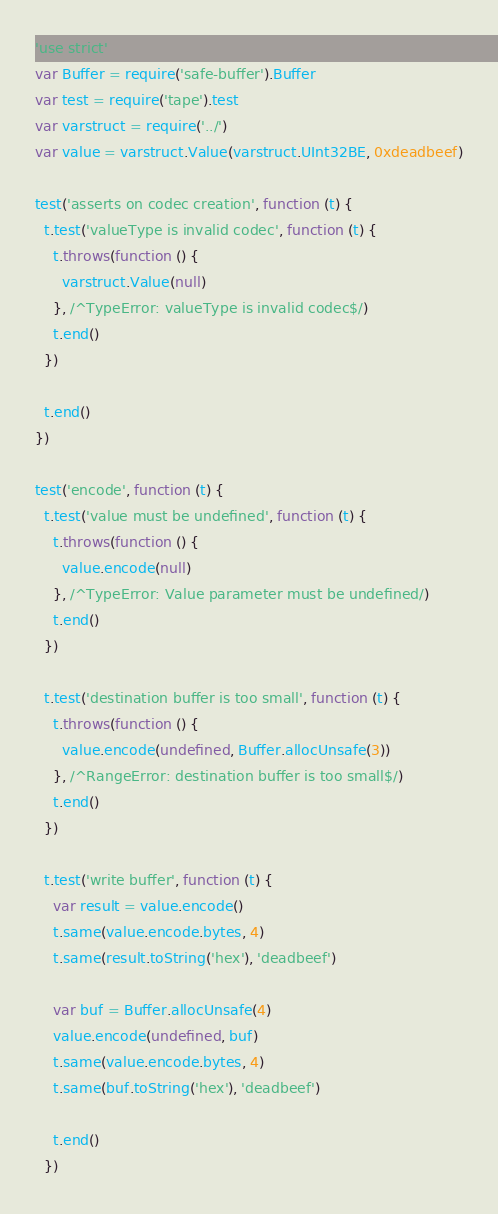<code> <loc_0><loc_0><loc_500><loc_500><_JavaScript_>'use strict'
var Buffer = require('safe-buffer').Buffer
var test = require('tape').test
var varstruct = require('../')
var value = varstruct.Value(varstruct.UInt32BE, 0xdeadbeef)

test('asserts on codec creation', function (t) {
  t.test('valueType is invalid codec', function (t) {
    t.throws(function () {
      varstruct.Value(null)
    }, /^TypeError: valueType is invalid codec$/)
    t.end()
  })

  t.end()
})

test('encode', function (t) {
  t.test('value must be undefined', function (t) {
    t.throws(function () {
      value.encode(null)
    }, /^TypeError: Value parameter must be undefined/)
    t.end()
  })

  t.test('destination buffer is too small', function (t) {
    t.throws(function () {
      value.encode(undefined, Buffer.allocUnsafe(3))
    }, /^RangeError: destination buffer is too small$/)
    t.end()
  })

  t.test('write buffer', function (t) {
    var result = value.encode()
    t.same(value.encode.bytes, 4)
    t.same(result.toString('hex'), 'deadbeef')

    var buf = Buffer.allocUnsafe(4)
    value.encode(undefined, buf)
    t.same(value.encode.bytes, 4)
    t.same(buf.toString('hex'), 'deadbeef')

    t.end()
  })
</code> 